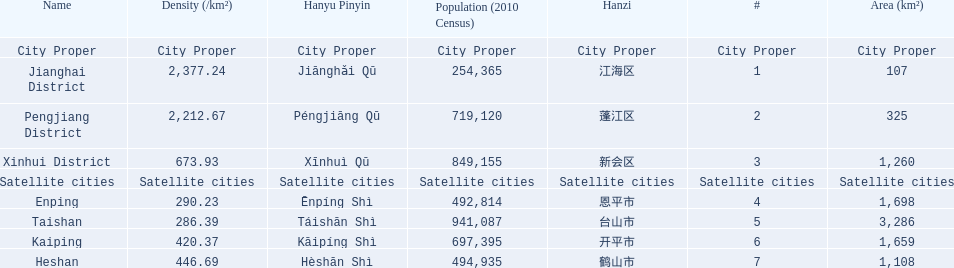What are all of the satellite cities? Enping, Taishan, Kaiping, Heshan. Of these, which has the highest population? Taishan. 